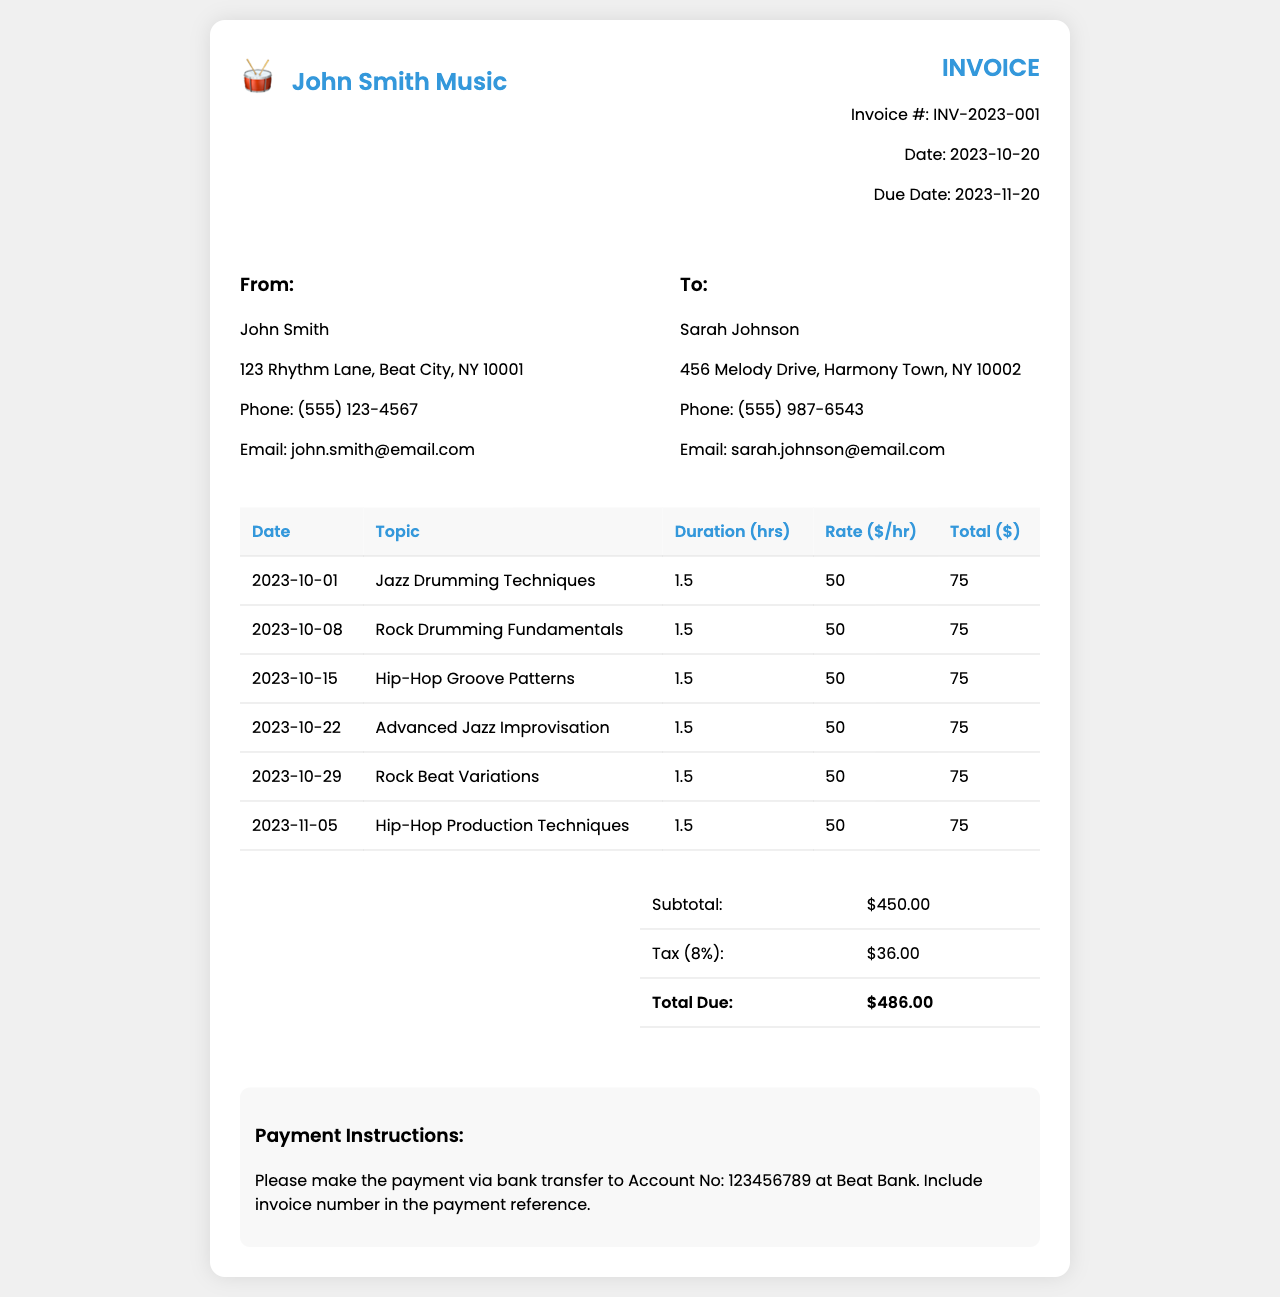What is the invoice number? The invoice number is a unique identifier for this invoice, located in the invoice details.
Answer: INV-2023-001 What is the total due amount? The total due amount is calculated at the bottom of the invoice summary.
Answer: $486.00 Who is the recipient of the invoice? The recipient information is found in the "To" section of the invoice.
Answer: Sarah Johnson What is the due date for payment? The due date is specified in the invoice details.
Answer: 2023-11-20 How many hours were spent on the Jazz Drumming Techniques lesson? The duration for this specific lesson can be found in the table under "Duration (hrs)."
Answer: 1.5 What is the rate charged per hour for the lessons? The hourly rate is mentioned in the table and applies to all lessons.
Answer: $50 How many lessons are listed in total? The total number of lessons can be counted from the entries in the table.
Answer: 6 What is the tax percentage applied to the invoice? The tax percentage is indicated in the summary section of the invoice.
Answer: 8% What payment method is suggested in the invoice? The payment method is specified in the payment instructions section at the end of the invoice.
Answer: Bank transfer What topic was covered in the session on 2023-10-15? The date and corresponding lesson topic are recorded in the table.
Answer: Hip-Hop Groove Patterns 